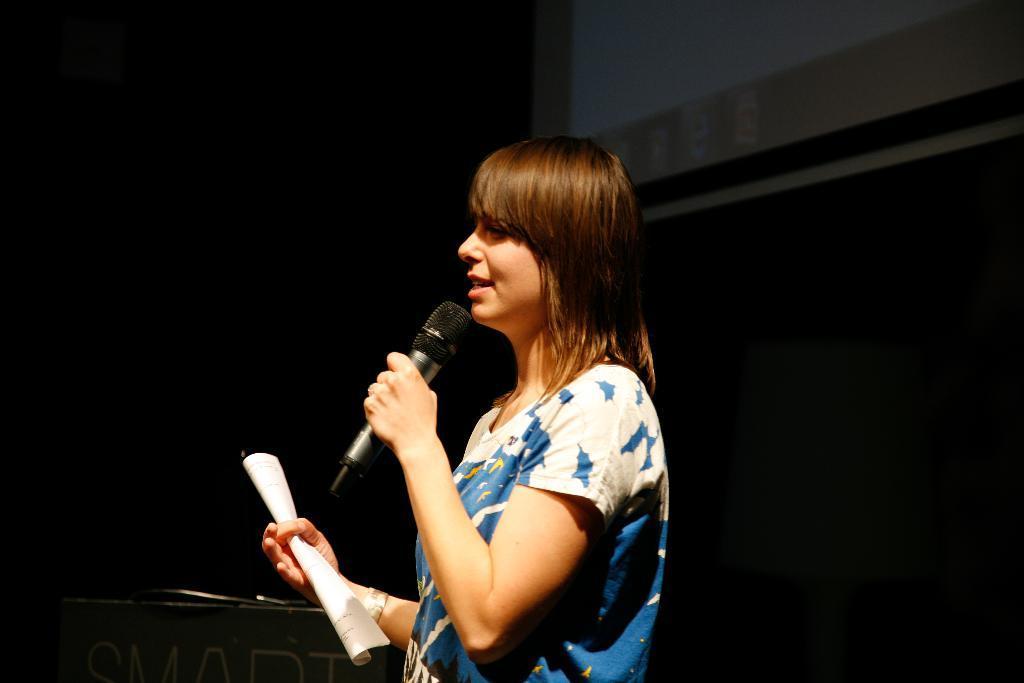In one or two sentences, can you explain what this image depicts? a person is standing facing her left. a paper in her hand and a microphone in other hand. she is wearing a blue and white colored t shirt. 